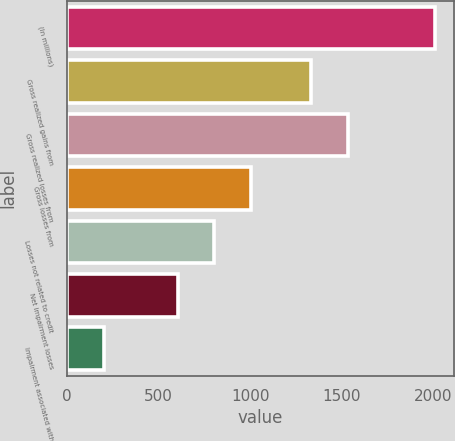Convert chart to OTSL. <chart><loc_0><loc_0><loc_500><loc_500><bar_chart><fcel>(In millions)<fcel>Gross realized gains from<fcel>Gross realized losses from<fcel>Gross losses from<fcel>Losses not related to credit<fcel>Net impairment losses<fcel>Impairment associated with<nl><fcel>2010<fcel>1330<fcel>1530.9<fcel>1005.5<fcel>804.6<fcel>603.7<fcel>201.9<nl></chart> 